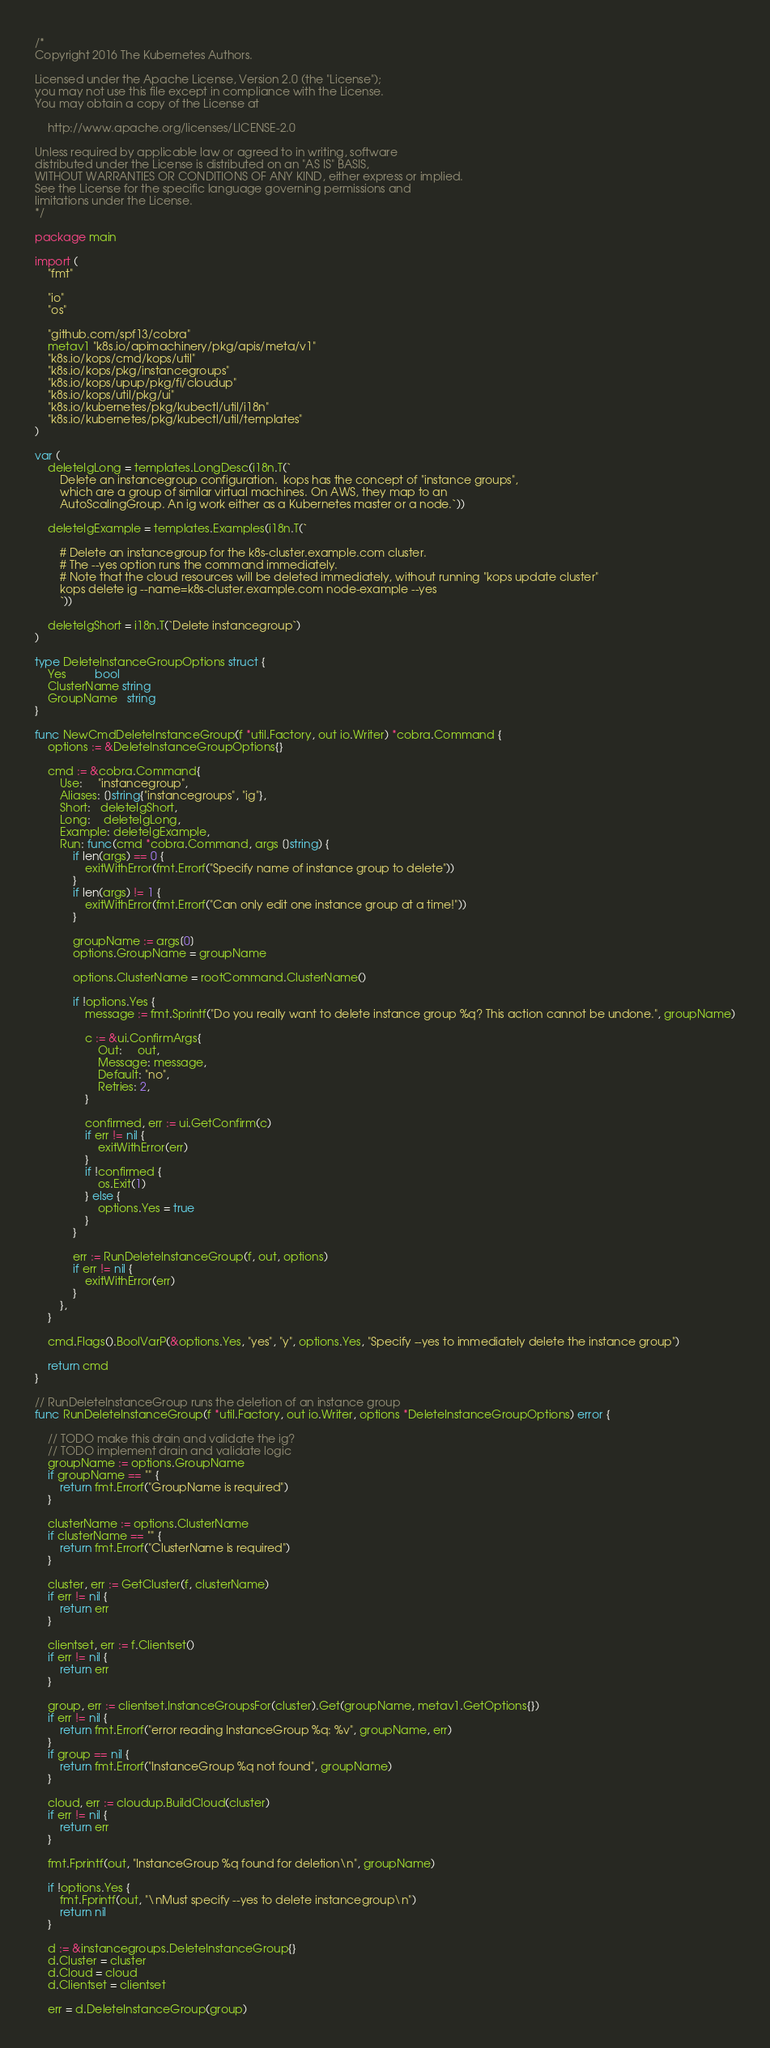<code> <loc_0><loc_0><loc_500><loc_500><_Go_>/*
Copyright 2016 The Kubernetes Authors.

Licensed under the Apache License, Version 2.0 (the "License");
you may not use this file except in compliance with the License.
You may obtain a copy of the License at

    http://www.apache.org/licenses/LICENSE-2.0

Unless required by applicable law or agreed to in writing, software
distributed under the License is distributed on an "AS IS" BASIS,
WITHOUT WARRANTIES OR CONDITIONS OF ANY KIND, either express or implied.
See the License for the specific language governing permissions and
limitations under the License.
*/

package main

import (
	"fmt"

	"io"
	"os"

	"github.com/spf13/cobra"
	metav1 "k8s.io/apimachinery/pkg/apis/meta/v1"
	"k8s.io/kops/cmd/kops/util"
	"k8s.io/kops/pkg/instancegroups"
	"k8s.io/kops/upup/pkg/fi/cloudup"
	"k8s.io/kops/util/pkg/ui"
	"k8s.io/kubernetes/pkg/kubectl/util/i18n"
	"k8s.io/kubernetes/pkg/kubectl/util/templates"
)

var (
	deleteIgLong = templates.LongDesc(i18n.T(`
		Delete an instancegroup configuration.  kops has the concept of "instance groups",
		which are a group of similar virtual machines. On AWS, they map to an
		AutoScalingGroup. An ig work either as a Kubernetes master or a node.`))

	deleteIgExample = templates.Examples(i18n.T(`

		# Delete an instancegroup for the k8s-cluster.example.com cluster.
		# The --yes option runs the command immediately.
		# Note that the cloud resources will be deleted immediately, without running "kops update cluster"
		kops delete ig --name=k8s-cluster.example.com node-example --yes
		`))

	deleteIgShort = i18n.T(`Delete instancegroup`)
)

type DeleteInstanceGroupOptions struct {
	Yes         bool
	ClusterName string
	GroupName   string
}

func NewCmdDeleteInstanceGroup(f *util.Factory, out io.Writer) *cobra.Command {
	options := &DeleteInstanceGroupOptions{}

	cmd := &cobra.Command{
		Use:     "instancegroup",
		Aliases: []string{"instancegroups", "ig"},
		Short:   deleteIgShort,
		Long:    deleteIgLong,
		Example: deleteIgExample,
		Run: func(cmd *cobra.Command, args []string) {
			if len(args) == 0 {
				exitWithError(fmt.Errorf("Specify name of instance group to delete"))
			}
			if len(args) != 1 {
				exitWithError(fmt.Errorf("Can only edit one instance group at a time!"))
			}

			groupName := args[0]
			options.GroupName = groupName

			options.ClusterName = rootCommand.ClusterName()

			if !options.Yes {
				message := fmt.Sprintf("Do you really want to delete instance group %q? This action cannot be undone.", groupName)

				c := &ui.ConfirmArgs{
					Out:     out,
					Message: message,
					Default: "no",
					Retries: 2,
				}

				confirmed, err := ui.GetConfirm(c)
				if err != nil {
					exitWithError(err)
				}
				if !confirmed {
					os.Exit(1)
				} else {
					options.Yes = true
				}
			}

			err := RunDeleteInstanceGroup(f, out, options)
			if err != nil {
				exitWithError(err)
			}
		},
	}

	cmd.Flags().BoolVarP(&options.Yes, "yes", "y", options.Yes, "Specify --yes to immediately delete the instance group")

	return cmd
}

// RunDeleteInstanceGroup runs the deletion of an instance group
func RunDeleteInstanceGroup(f *util.Factory, out io.Writer, options *DeleteInstanceGroupOptions) error {

	// TODO make this drain and validate the ig?
	// TODO implement drain and validate logic
	groupName := options.GroupName
	if groupName == "" {
		return fmt.Errorf("GroupName is required")
	}

	clusterName := options.ClusterName
	if clusterName == "" {
		return fmt.Errorf("ClusterName is required")
	}

	cluster, err := GetCluster(f, clusterName)
	if err != nil {
		return err
	}

	clientset, err := f.Clientset()
	if err != nil {
		return err
	}

	group, err := clientset.InstanceGroupsFor(cluster).Get(groupName, metav1.GetOptions{})
	if err != nil {
		return fmt.Errorf("error reading InstanceGroup %q: %v", groupName, err)
	}
	if group == nil {
		return fmt.Errorf("InstanceGroup %q not found", groupName)
	}

	cloud, err := cloudup.BuildCloud(cluster)
	if err != nil {
		return err
	}

	fmt.Fprintf(out, "InstanceGroup %q found for deletion\n", groupName)

	if !options.Yes {
		fmt.Fprintf(out, "\nMust specify --yes to delete instancegroup\n")
		return nil
	}

	d := &instancegroups.DeleteInstanceGroup{}
	d.Cluster = cluster
	d.Cloud = cloud
	d.Clientset = clientset

	err = d.DeleteInstanceGroup(group)</code> 